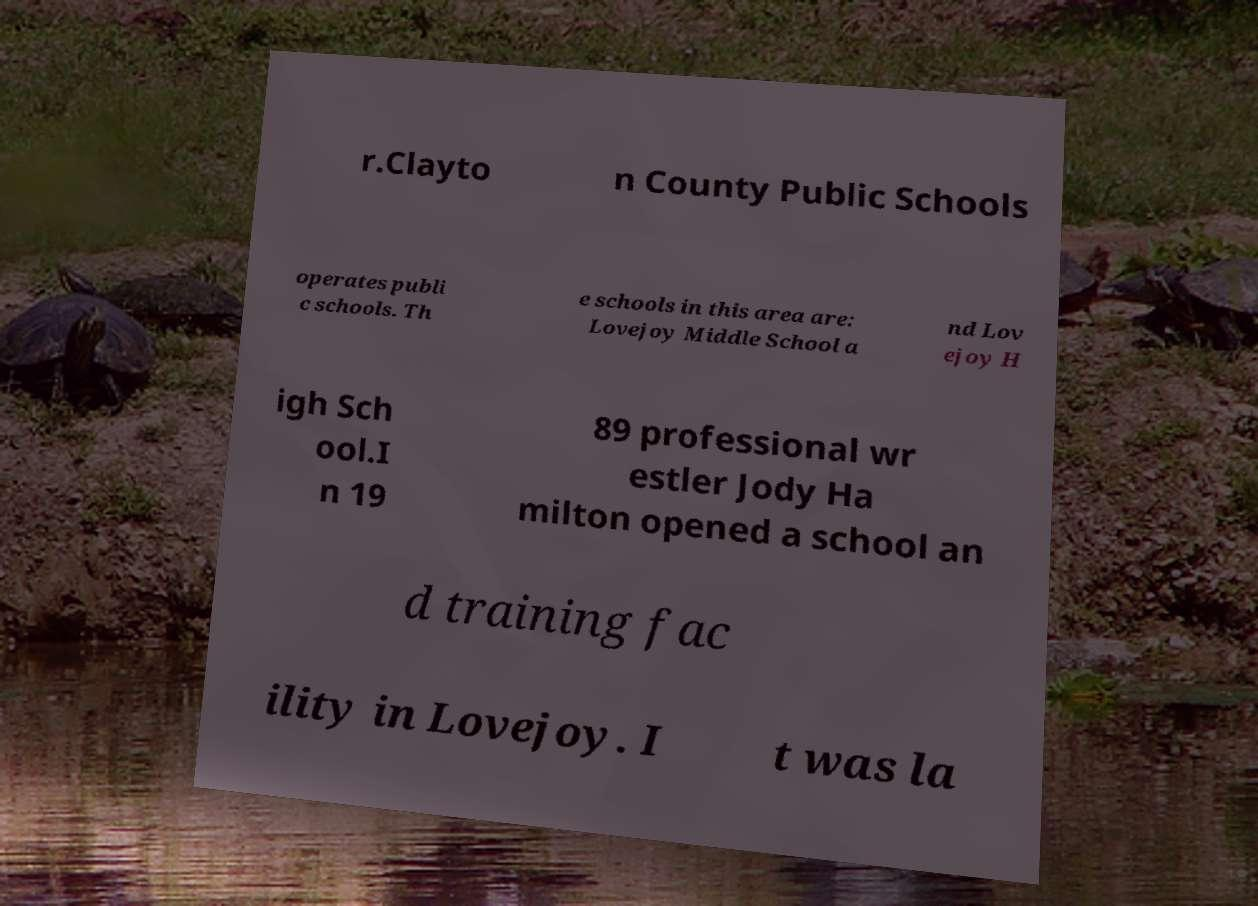There's text embedded in this image that I need extracted. Can you transcribe it verbatim? r.Clayto n County Public Schools operates publi c schools. Th e schools in this area are: Lovejoy Middle School a nd Lov ejoy H igh Sch ool.I n 19 89 professional wr estler Jody Ha milton opened a school an d training fac ility in Lovejoy. I t was la 